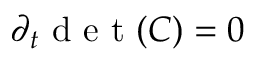<formula> <loc_0><loc_0><loc_500><loc_500>\partial _ { t } d e t ( C ) = 0</formula> 